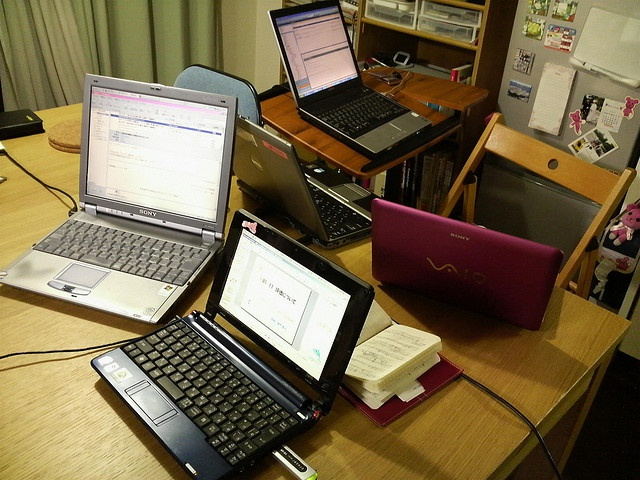Describe the objects in this image and their specific colors. I can see dining table in olive, black, ivory, and tan tones, laptop in olive, black, ivory, gray, and darkgray tones, laptop in olive, ivory, darkgray, and gray tones, refrigerator in olive, tan, and gray tones, and chair in olive, black, and maroon tones in this image. 